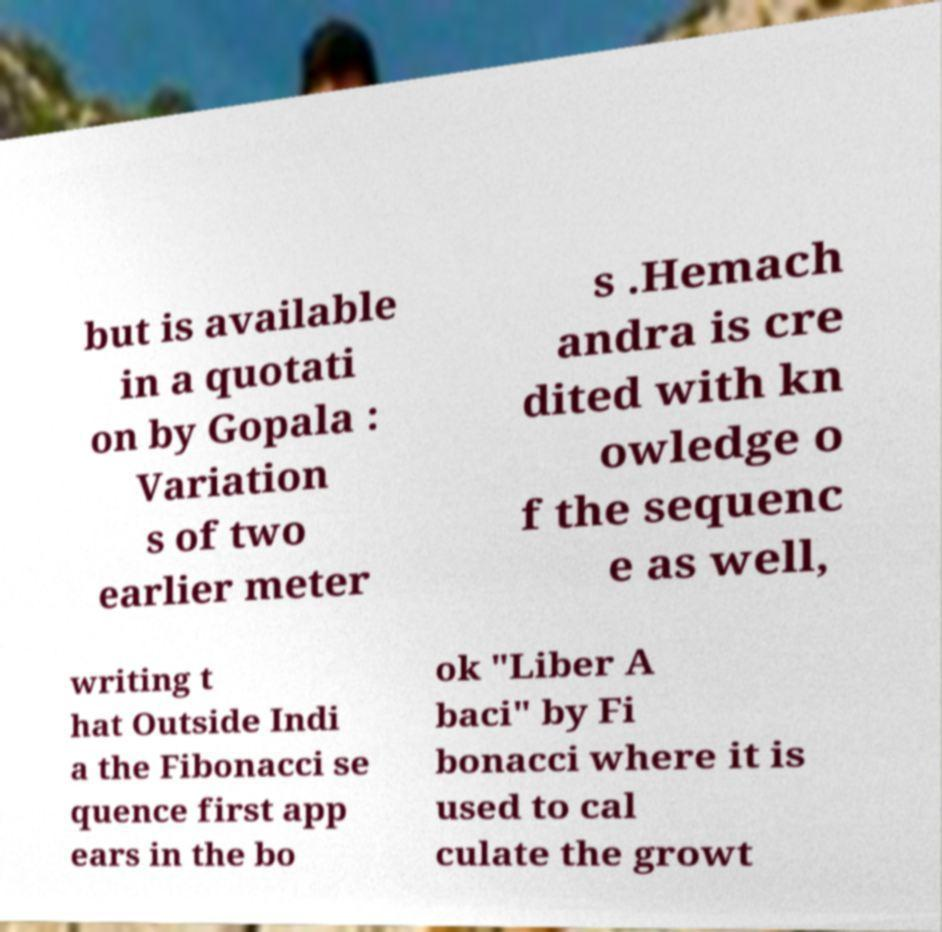Please read and relay the text visible in this image. What does it say? but is available in a quotati on by Gopala : Variation s of two earlier meter s .Hemach andra is cre dited with kn owledge o f the sequenc e as well, writing t hat Outside Indi a the Fibonacci se quence first app ears in the bo ok "Liber A baci" by Fi bonacci where it is used to cal culate the growt 